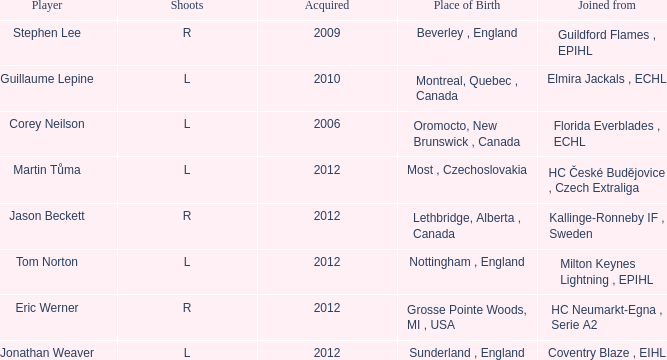Who acquired tom norton? 2012.0. 